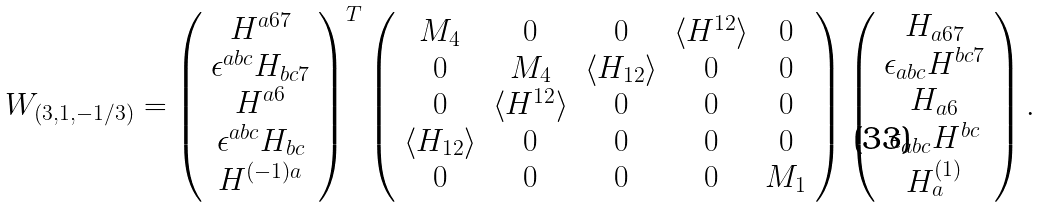<formula> <loc_0><loc_0><loc_500><loc_500>W _ { ( 3 , 1 , - 1 / 3 ) } = \left ( \begin{array} { c } H ^ { a 6 7 } \\ \epsilon ^ { a b c } H _ { b c 7 } \\ H ^ { a 6 } \\ \epsilon ^ { a b c } H _ { b c } \\ H ^ { ( - 1 ) a } \end{array} \right ) ^ { T } \left ( \begin{array} { c c c c c } M _ { 4 } & 0 & 0 & \langle H ^ { 1 2 } \rangle & 0 \\ 0 & M _ { 4 } & \langle H _ { 1 2 } \rangle & 0 & 0 \\ 0 & \langle H ^ { 1 2 } \rangle & 0 & 0 & 0 \\ \langle H _ { 1 2 } \rangle & 0 & 0 & 0 & 0 \\ 0 & 0 & 0 & 0 & M _ { 1 } \end{array} \right ) \left ( \begin{array} { c } H _ { a 6 7 } \\ \epsilon _ { a b c } H ^ { b c 7 } \\ H _ { a 6 } \\ \epsilon _ { a b c } H ^ { b c } \\ H ^ { ( 1 ) } _ { a } \end{array} \right ) .</formula> 